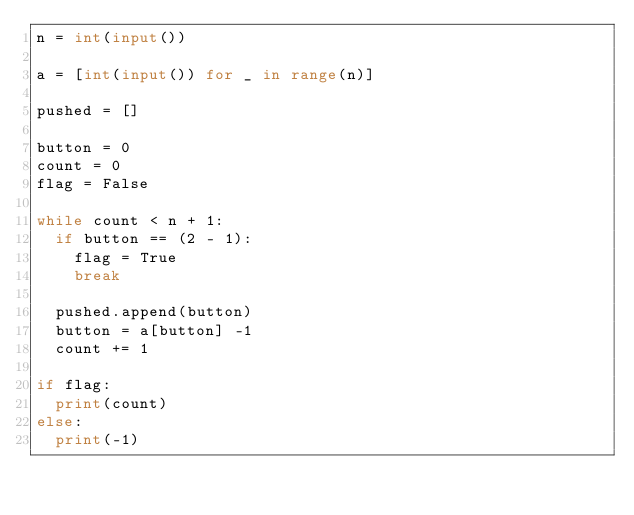Convert code to text. <code><loc_0><loc_0><loc_500><loc_500><_Python_>n = int(input())

a = [int(input()) for _ in range(n)]

pushed = []

button = 0
count = 0
flag = False

while count < n + 1:
	if button == (2 - 1):
		flag = True
		break
	
	pushed.append(button)
	button = a[button] -1
	count += 1
	
if flag:
	print(count)
else:
	print(-1)</code> 